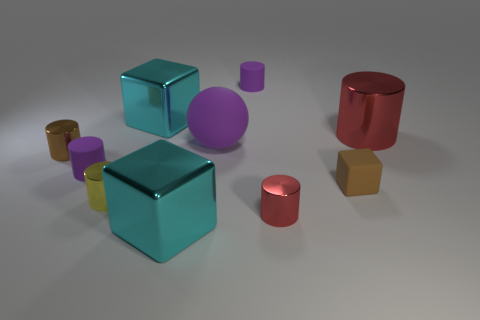How many yellow objects are either large rubber spheres or blocks?
Ensure brevity in your answer.  0. Are there fewer small purple matte cylinders that are behind the big ball than red metal cylinders?
Offer a terse response. Yes. There is a cyan shiny cube that is behind the tiny brown shiny cylinder; what number of tiny red things are behind it?
Provide a short and direct response. 0. What number of other things are there of the same size as the brown metal object?
Keep it short and to the point. 5. What number of objects are big metallic things or purple matte things that are to the right of the big purple matte object?
Provide a succinct answer. 4. Is the number of cyan metallic objects less than the number of small cyan cubes?
Keep it short and to the point. No. There is a rubber cylinder right of the big cyan metal thing that is in front of the big rubber sphere; what color is it?
Your answer should be compact. Purple. How many rubber things are tiny cubes or red things?
Your answer should be compact. 1. Is the material of the purple cylinder in front of the brown metal cylinder the same as the large cube that is in front of the large red shiny cylinder?
Keep it short and to the point. No. Is there a small red shiny thing?
Keep it short and to the point. Yes. 